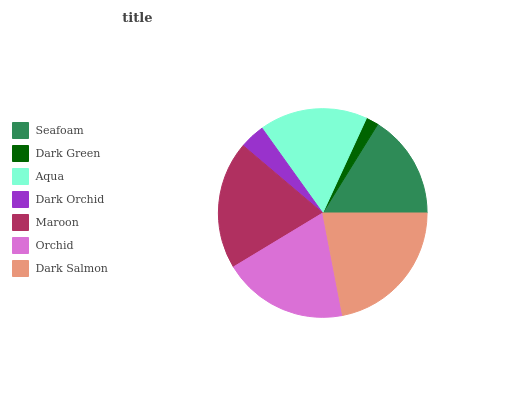Is Dark Green the minimum?
Answer yes or no. Yes. Is Dark Salmon the maximum?
Answer yes or no. Yes. Is Aqua the minimum?
Answer yes or no. No. Is Aqua the maximum?
Answer yes or no. No. Is Aqua greater than Dark Green?
Answer yes or no. Yes. Is Dark Green less than Aqua?
Answer yes or no. Yes. Is Dark Green greater than Aqua?
Answer yes or no. No. Is Aqua less than Dark Green?
Answer yes or no. No. Is Aqua the high median?
Answer yes or no. Yes. Is Aqua the low median?
Answer yes or no. Yes. Is Dark Orchid the high median?
Answer yes or no. No. Is Dark Salmon the low median?
Answer yes or no. No. 